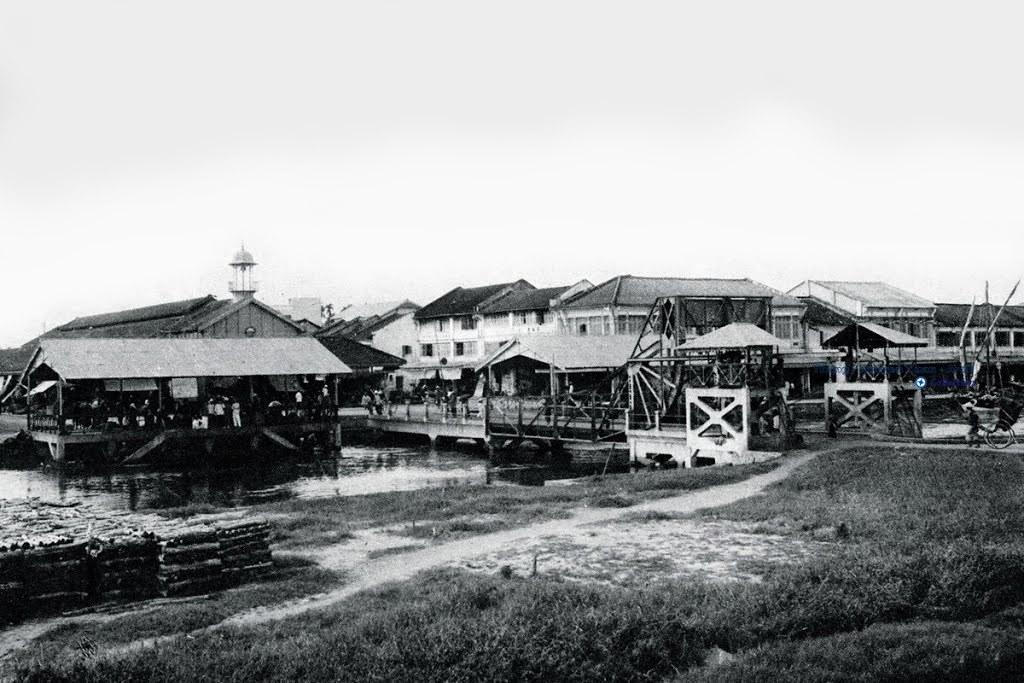In one or two sentences, can you explain what this image depicts? On the right side, there's grass on the ground. In the background, there are buildings which are having roofs, there is water and there are clouds in the sky. 